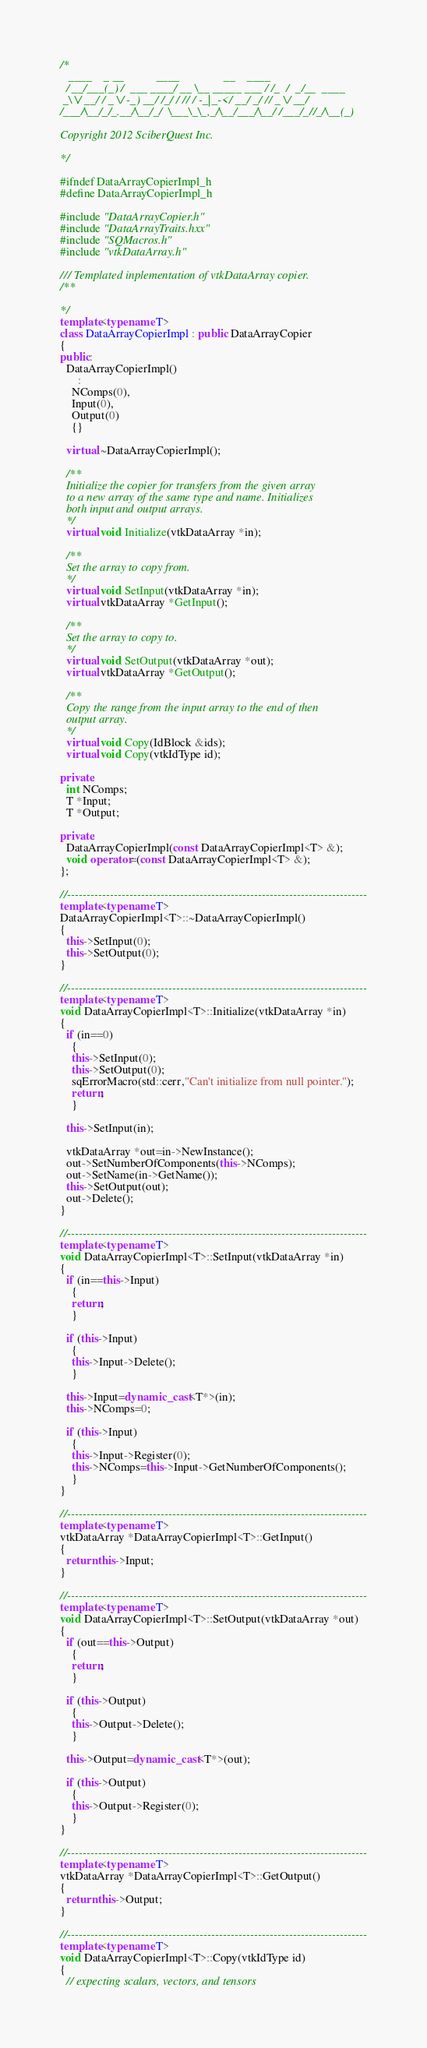<code> <loc_0><loc_0><loc_500><loc_500><_C++_>/*
   ____    _ __           ____               __    ____
  / __/___(_) /  ___ ____/ __ \__ _____ ___ / /_  /  _/__  ____
 _\ \/ __/ / _ \/ -_) __/ /_/ / // / -_|_-</ __/ _/ // _ \/ __/
/___/\__/_/_.__/\__/_/  \___\_\_,_/\__/___/\__/ /___/_//_/\__(_)

Copyright 2012 SciberQuest Inc.

*/

#ifndef DataArrayCopierImpl_h
#define DataArrayCopierImpl_h

#include "DataArrayCopier.h"
#include "DataArrayTraits.hxx"
#include "SQMacros.h"
#include "vtkDataArray.h"

/// Templated inplementation of vtkDataArray copier.
/**

*/
template<typename T>
class DataArrayCopierImpl : public DataArrayCopier
{
public:
  DataArrayCopierImpl()
      :
    NComps(0),
    Input(0),
    Output(0)
    {}

  virtual ~DataArrayCopierImpl();

  /**
  Initialize the copier for transfers from the given array
  to a new array of the same type and name. Initializes
  both input and output arrays.
  */
  virtual void Initialize(vtkDataArray *in);

  /**
  Set the array to copy from.
  */
  virtual void SetInput(vtkDataArray *in);
  virtual vtkDataArray *GetInput();

  /**
  Set the array to copy to.
  */
  virtual void SetOutput(vtkDataArray *out);
  virtual vtkDataArray *GetOutput();

  /**
  Copy the range from the input array to the end of then
  output array.
  */
  virtual void Copy(IdBlock &ids);
  virtual void Copy(vtkIdType id);

private:
  int NComps;
  T *Input;
  T *Output;

private:
  DataArrayCopierImpl(const DataArrayCopierImpl<T> &);
  void operator=(const DataArrayCopierImpl<T> &);
};

//-----------------------------------------------------------------------------
template<typename T>
DataArrayCopierImpl<T>::~DataArrayCopierImpl()
{
  this->SetInput(0);
  this->SetOutput(0);
}

//-----------------------------------------------------------------------------
template<typename T>
void DataArrayCopierImpl<T>::Initialize(vtkDataArray *in)
{
  if (in==0)
    {
    this->SetInput(0);
    this->SetOutput(0);
    sqErrorMacro(std::cerr,"Can't initialize from null pointer.");
    return;
    }

  this->SetInput(in);

  vtkDataArray *out=in->NewInstance();
  out->SetNumberOfComponents(this->NComps);
  out->SetName(in->GetName());
  this->SetOutput(out);
  out->Delete();
}

//-----------------------------------------------------------------------------
template<typename T>
void DataArrayCopierImpl<T>::SetInput(vtkDataArray *in)
{
  if (in==this->Input)
    {
    return;
    }

  if (this->Input)
    {
    this->Input->Delete();
    }

  this->Input=dynamic_cast<T*>(in);
  this->NComps=0;

  if (this->Input)
    {
    this->Input->Register(0);
    this->NComps=this->Input->GetNumberOfComponents();
    }
}

//-----------------------------------------------------------------------------
template<typename T>
vtkDataArray *DataArrayCopierImpl<T>::GetInput()
{
  return this->Input;
}

//-----------------------------------------------------------------------------
template<typename T>
void DataArrayCopierImpl<T>::SetOutput(vtkDataArray *out)
{
  if (out==this->Output)
    {
    return;
    }

  if (this->Output)
    {
    this->Output->Delete();
    }

  this->Output=dynamic_cast<T*>(out);

  if (this->Output)
    {
    this->Output->Register(0);
    }
}

//-----------------------------------------------------------------------------
template<typename T>
vtkDataArray *DataArrayCopierImpl<T>::GetOutput()
{
  return this->Output;
}

//-----------------------------------------------------------------------------
template<typename T>
void DataArrayCopierImpl<T>::Copy(vtkIdType id)
{
  // expecting scalars, vectors, and tensors</code> 